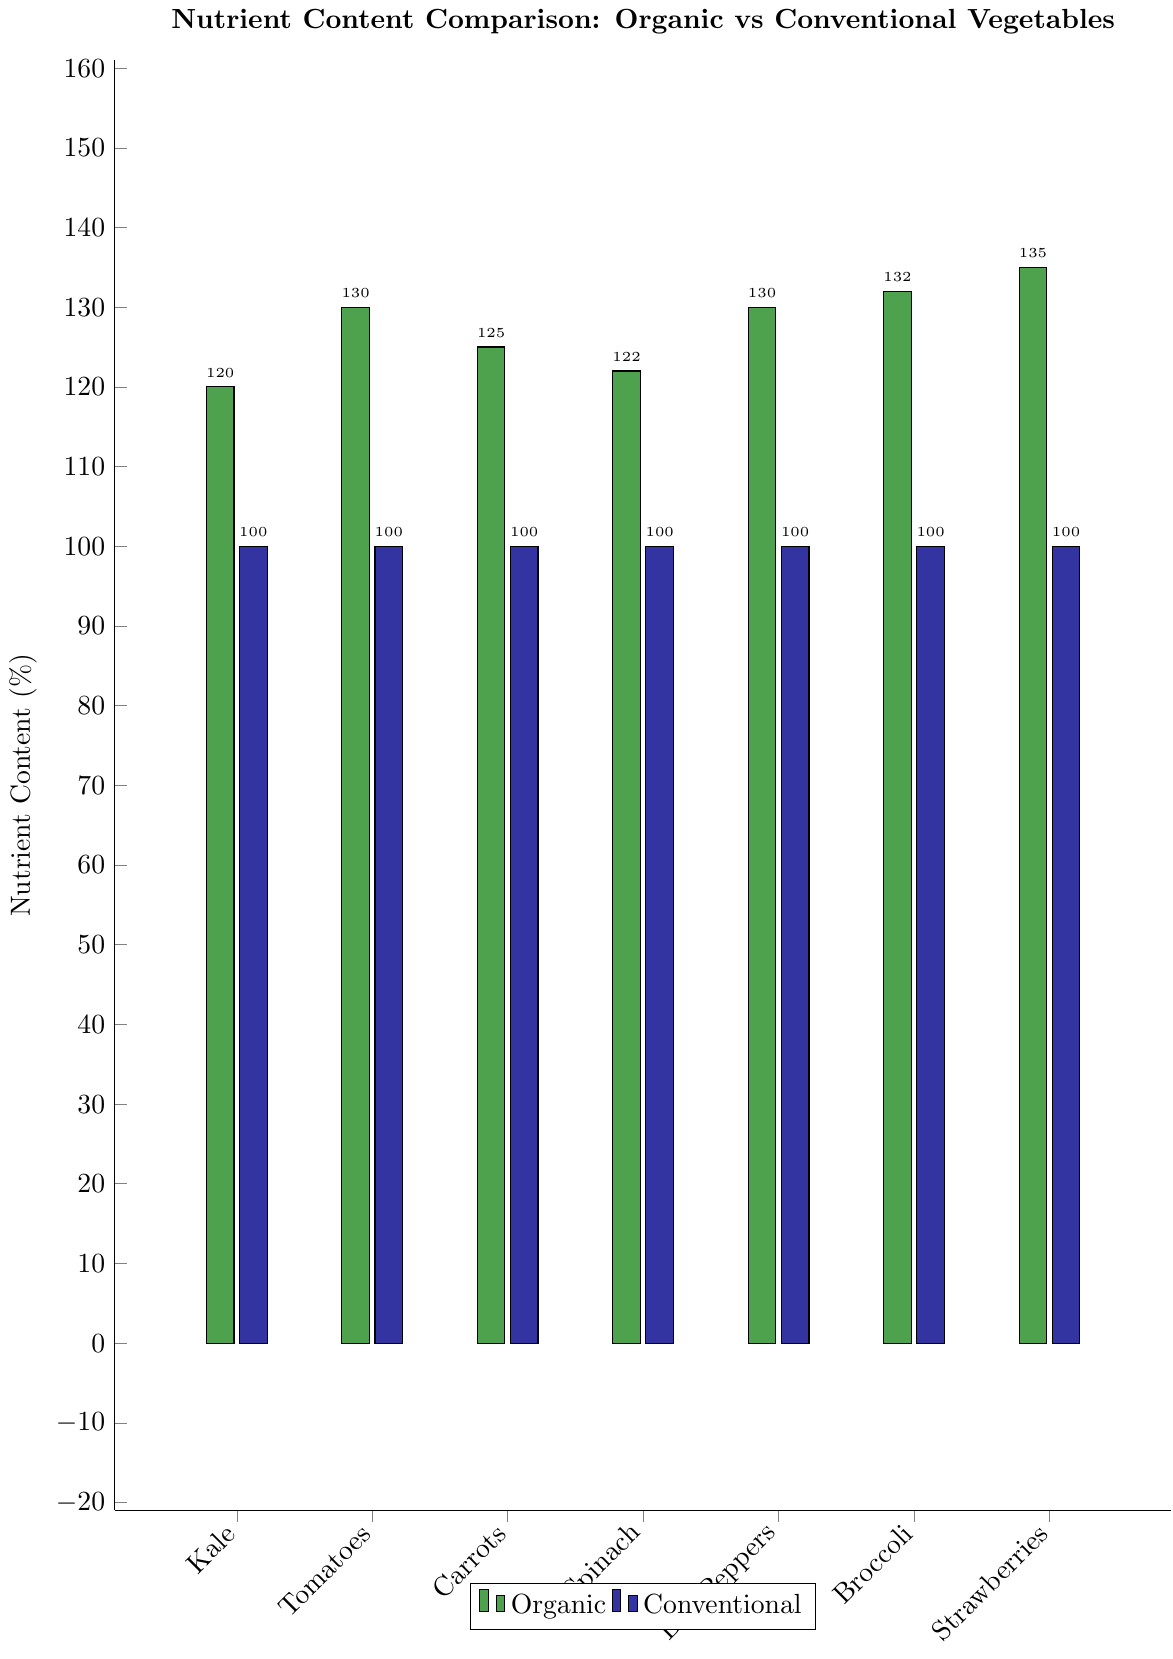What is the difference in Vitamin C content between organic and conventional Kale? The bar chart indicates that organic Kale has a Vitamin C content of 120%, while conventional Kale has a Vitamin C content of 100%. The difference between them is 120 - 100 = 20.
Answer: 20 Which vegetable shows the greatest increase in nutrient content when comparing organic to conventional? From the chart, we can see that the increase is greatest in Strawberries where the content for organic is 135% compared to 100% for conventional, resulting in an increase of 135 - 100 = 35.
Answer: Strawberries How many vegetables have an organic nutrient content of at least 130%? Observing the chart, Tomatoes (Lycopene and Vitamin C), Bell Peppers (Vitamin C), Broccoli (Glucosinolates), and Strawberries (Phenolic compounds) all have organic nutrient contents of at least 130%.
Answer: 4 Compare the nutrient content of organic and conventional Tomatoes. The organic Tomatoes have a Lycopene content of 130%, Vitamin C content of 110%, and Flavonoids content of 120%, while conventional Tomatoes have a content of 100% for all three nutrients. Therefore, for Organic vs Conventional: Lycopene (130 vs 100), Vitamin C (110 vs 100), and Flavonoids (120 vs 100).
Answer: Lycopene: 130 vs 100, Vitamin C: 110 vs 100, Flavonoids: 120 vs 100 What is the difference in Iron content between organic and conventional Spinach? The chart shows that organic Spinach has an Iron content of 118% while conventional Spinach has an Iron content of 100%. The difference is 118 - 100 = 18.
Answer: 18 What is the average increase in nutrient content across all listed vegetables when switching from conventional to organic? To find the average increase: (20 + 30 + 25 + 22 + 30 + 32 + 35) / 7 = 27.71 (rounded to 2 decimal places).
Answer: 27.71 Which organic vegetable has the lowest increase in nutrient content compared to conventional? By examining the chart, Spinach has the lowest increase where the highest organic content is 122% for Folate, resulting in an increase of 122 - 100 = 22.
Answer: Spinach Are there any vegetables where the Vitamin A content differs between organic and conventional? The chart shows that Carrots and Bell Peppers have Vitamin A content, with organic Carrots having 115% and conventional having 100%, and organic Bell Peppers having 115% and conventional having 100%. Thus, both show a difference of 15.
Answer: Yes What is the ratio of organic to conventional nutrient content for Broccoli's Glucosinolates? For Broccoli's Glucosinolates, the organic content is 132% and the conventional is 100%. The ratio is 132 / 100 = 1.32.
Answer: 1.32 Which vegetable has the highest Vitamin C content in organic form and how does it compare to its conventional form? Bell Peppers have the highest Vitamin C content in organic form at 130%. Comparing with its conventional form stands at 100%; the increase is 30 (130 - 100).
Answer: Bell Peppers: 130 vs 100 (increase of 30) 